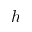<formula> <loc_0><loc_0><loc_500><loc_500>h</formula> 